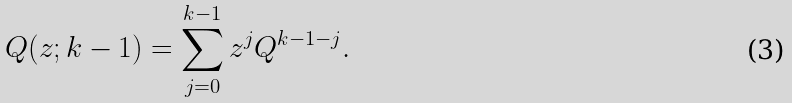<formula> <loc_0><loc_0><loc_500><loc_500>Q ( z ; k - 1 ) = \sum _ { j = 0 } ^ { k - 1 } z ^ { j } Q ^ { k - 1 - j } .</formula> 